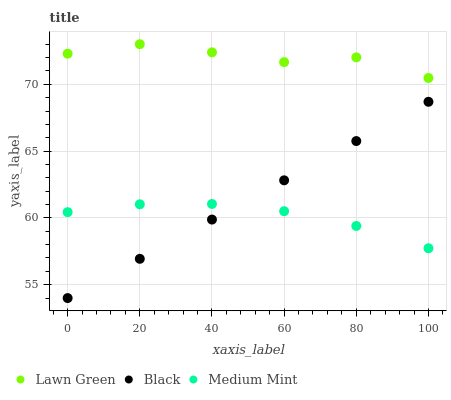Does Medium Mint have the minimum area under the curve?
Answer yes or no. Yes. Does Lawn Green have the maximum area under the curve?
Answer yes or no. Yes. Does Black have the minimum area under the curve?
Answer yes or no. No. Does Black have the maximum area under the curve?
Answer yes or no. No. Is Black the smoothest?
Answer yes or no. Yes. Is Lawn Green the roughest?
Answer yes or no. Yes. Is Lawn Green the smoothest?
Answer yes or no. No. Is Black the roughest?
Answer yes or no. No. Does Black have the lowest value?
Answer yes or no. Yes. Does Lawn Green have the lowest value?
Answer yes or no. No. Does Lawn Green have the highest value?
Answer yes or no. Yes. Does Black have the highest value?
Answer yes or no. No. Is Black less than Lawn Green?
Answer yes or no. Yes. Is Lawn Green greater than Medium Mint?
Answer yes or no. Yes. Does Medium Mint intersect Black?
Answer yes or no. Yes. Is Medium Mint less than Black?
Answer yes or no. No. Is Medium Mint greater than Black?
Answer yes or no. No. Does Black intersect Lawn Green?
Answer yes or no. No. 